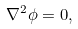Convert formula to latex. <formula><loc_0><loc_0><loc_500><loc_500>\nabla ^ { 2 } \phi = 0 ,</formula> 